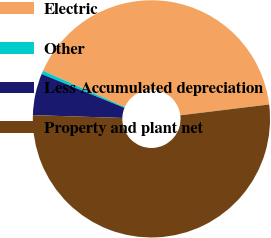<chart> <loc_0><loc_0><loc_500><loc_500><pie_chart><fcel>Electric<fcel>Other<fcel>Less Accumulated depreciation<fcel>Property and plant net<nl><fcel>41.42%<fcel>0.47%<fcel>5.67%<fcel>52.43%<nl></chart> 